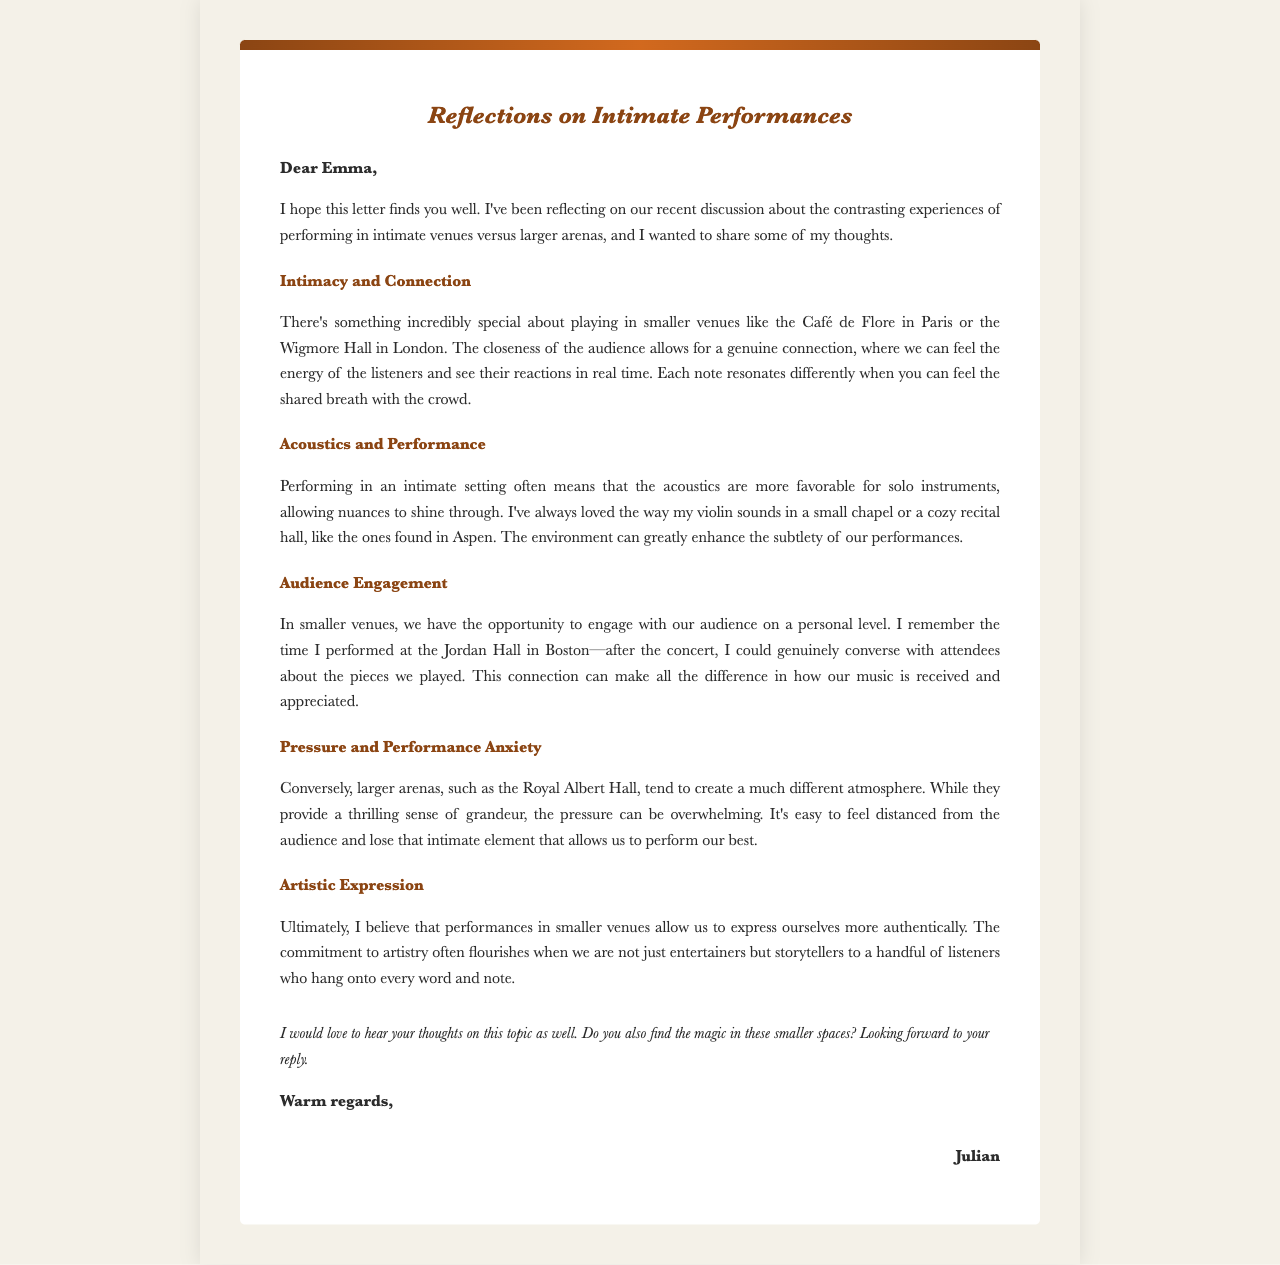what is the title of the letter? The title of the letter is at the top of the document, indicating the main subject of the correspondence.
Answer: Reflections on Intimate Performances who is the letter addressed to? The recipient of the letter is mentioned in the greeting section of the document.
Answer: Emma which two venues are mentioned in the context of intimacy and connection? The letter refers to specific venues to illustrate the difference in performance settings.
Answer: Café de Flore, Wigmore Hall what does Julian say about performing in smaller venues? This refers to Julian's feelings and thoughts regarding performing in smaller venues discussed in the letter.
Answer: Genuine connection how does Julian describe the audience experience in smaller venues? The letter explains how performing in smaller venues allows for a particular type of audience engagement.
Answer: Personal level what is a concern expressed about performing in larger arenas? This question refers to Julian’s thoughts on the challenges of larger performance settings.
Answer: Overwhelming pressure name one benefit of performing in intimate settings according to the letter. The document outlines multiple benefits of small venue performances.
Answer: Authentic artistic expression what does Julian want to know from Emma at the end of the letter? The closing paragraph invites Emma to share her thoughts on a specific aspect of music performance.
Answer: Her thoughts on smaller spaces 